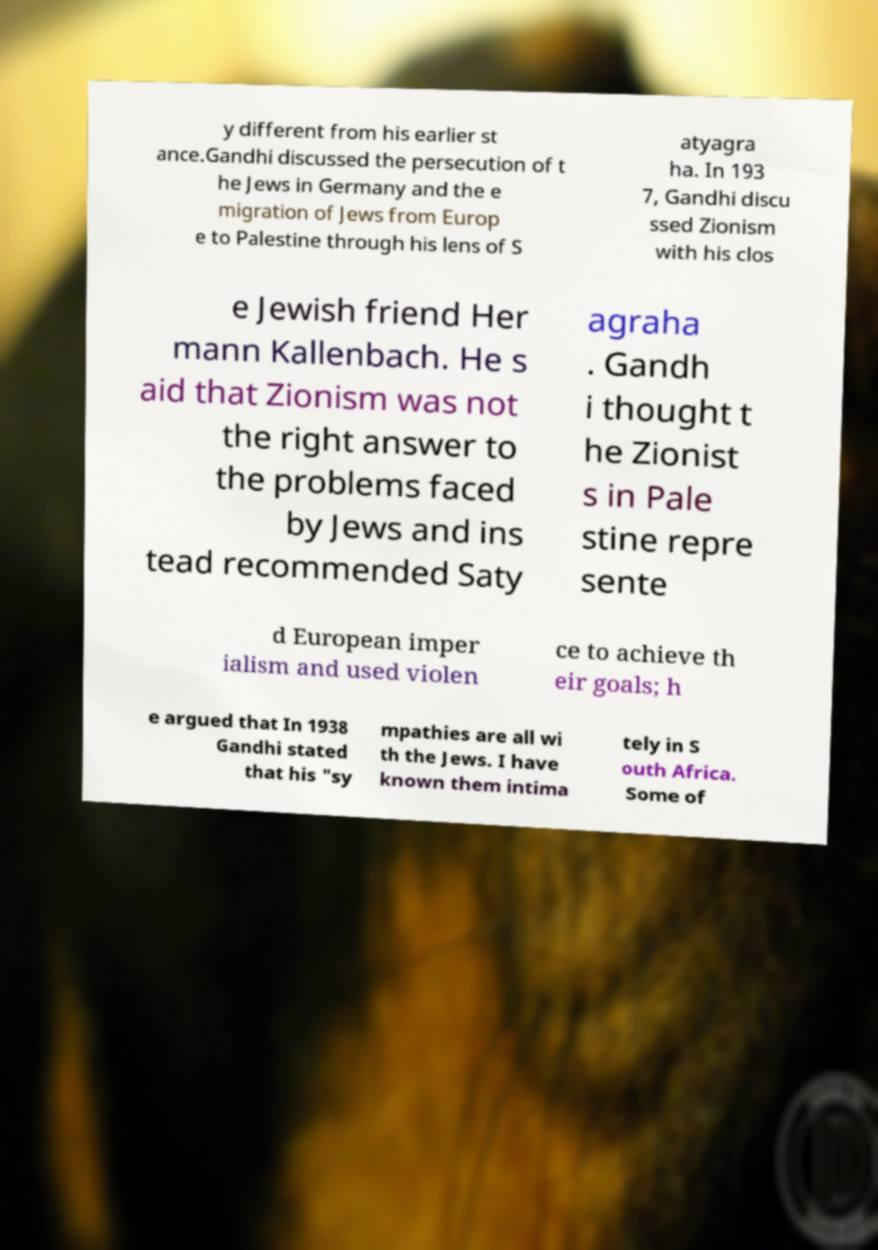For documentation purposes, I need the text within this image transcribed. Could you provide that? y different from his earlier st ance.Gandhi discussed the persecution of t he Jews in Germany and the e migration of Jews from Europ e to Palestine through his lens of S atyagra ha. In 193 7, Gandhi discu ssed Zionism with his clos e Jewish friend Her mann Kallenbach. He s aid that Zionism was not the right answer to the problems faced by Jews and ins tead recommended Saty agraha . Gandh i thought t he Zionist s in Pale stine repre sente d European imper ialism and used violen ce to achieve th eir goals; h e argued that In 1938 Gandhi stated that his "sy mpathies are all wi th the Jews. I have known them intima tely in S outh Africa. Some of 